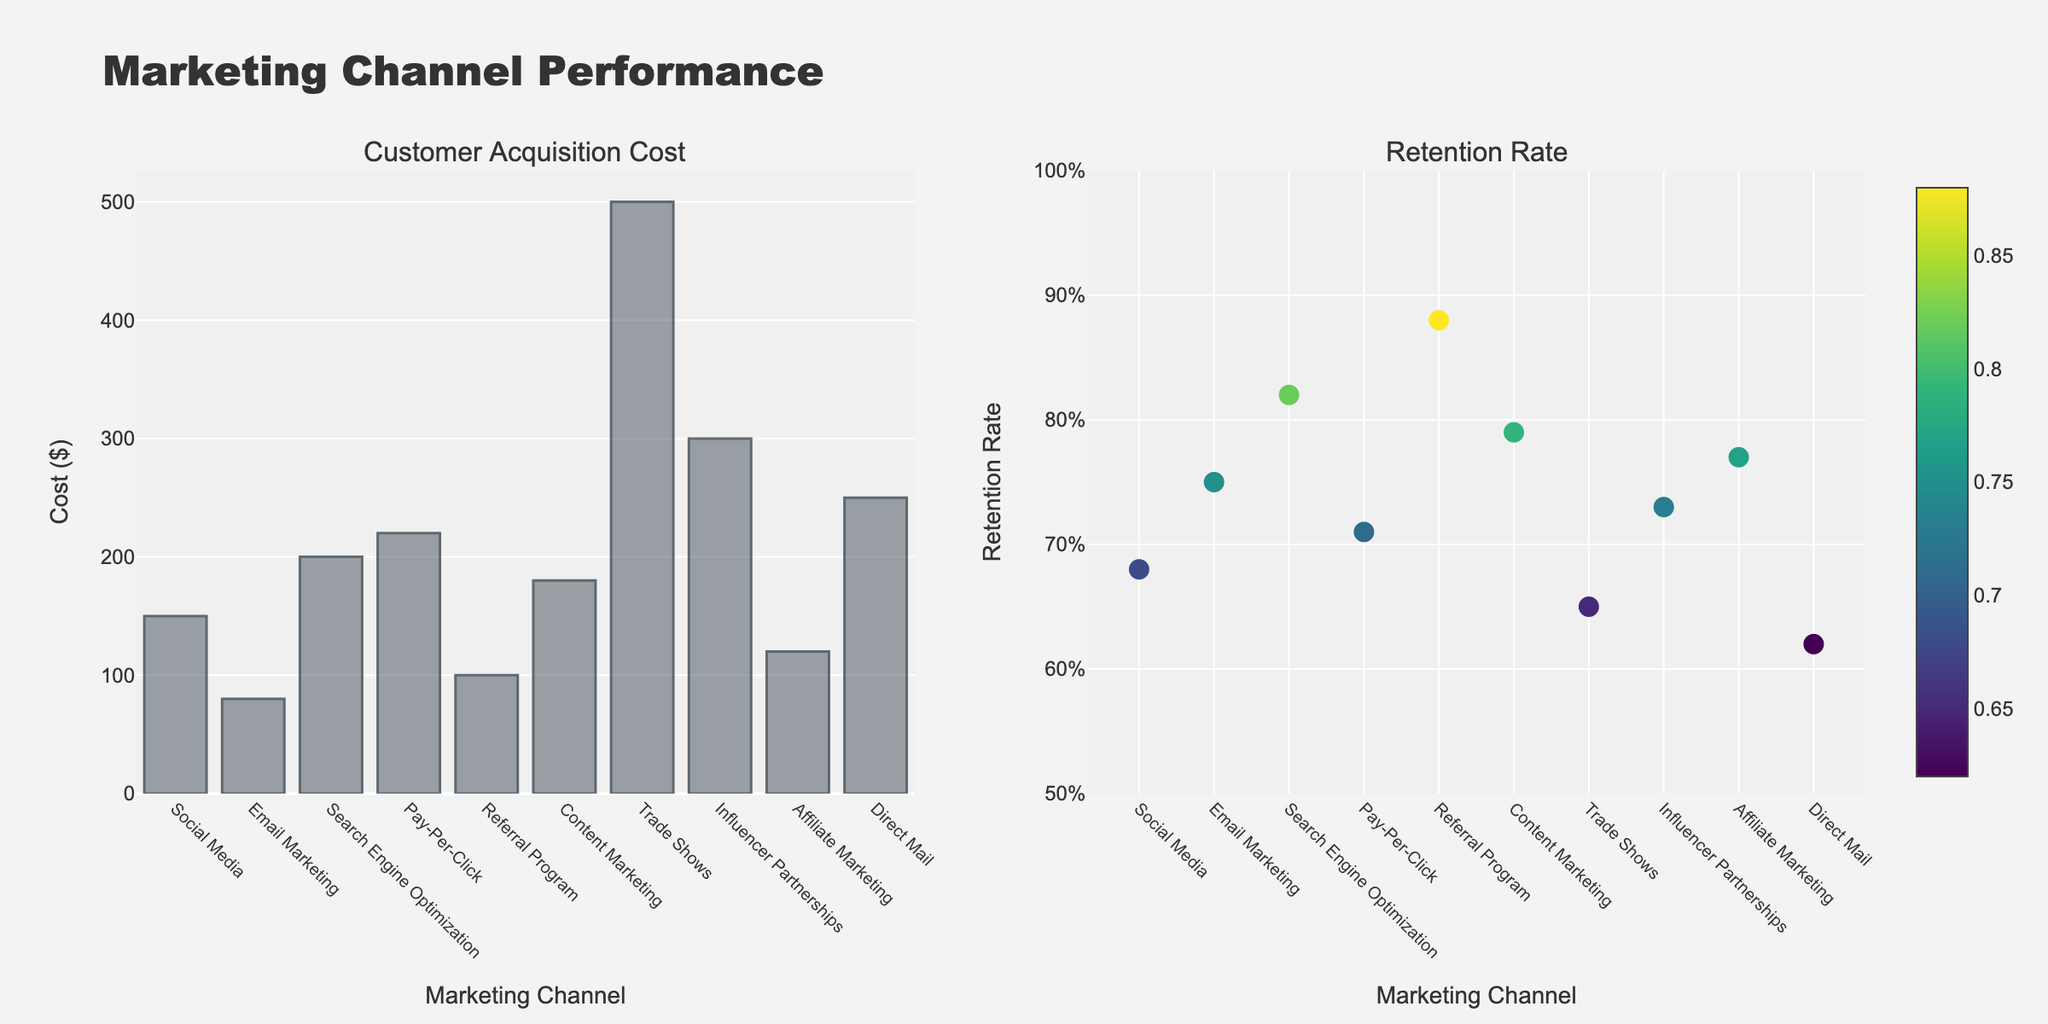What's the Marketing Channel with the highest Customer Acquisition Cost? Observe the left plot (bar chart) and identify the bar with the highest value. The 'Trade Shows' bar is the tallest.
Answer: Trade Shows Which Marketing Channel has the highest Retention Rate? Look at the right plot (scatter chart) and identify the marker that is positioned the highest on the y-axis. The marker for 'Referral Program' is the highest.
Answer: Referral Program Among Social Media and Email Marketing, which has a lower Customer Acquisition Cost? Compare the heights of the bars for 'Social Media' and 'Email Marketing' in the bar chart. The 'Email Marketing' bar is shorter.
Answer: Email Marketing What is the approximate difference in Retention Rate between Pay-Per-Click and Direct Mail? In the scatter plot, find the y-values for 'Pay-Per-Click' (~0.71) and 'Direct Mail' (~0.62). Calculate the difference (0.71 - 0.62).
Answer: 0.09 Which Marketing Channels have a Customer Acquisition Cost greater than $200? Identify the bars in the bar chart that extend above the $200 mark. These are 'Search Engine Optimization', 'Pay-Per-Click', 'Influencer Partnerships', 'Direct Mail', and 'Trade Shows'.
Answer: 5 Is the Retention Rate of Social Media higher than that of Content Marketing? Compare the positions of the 'Social Media' and 'Content Marketing' markers on the scatter plot. The 'Social Media' marker is lower.
Answer: No What is the average Customer Acquisition Cost across all Marketing Channels? Sum the y-values of all bars in the bar chart and divide by the number of bars (150+80+200+220+100+180+500+300+120+250)/10.
Answer: 210 Among the Marketing Channels listed, which one has both the lowest Customer Acquisition Cost and a high Retention Rate? Identify the bar with the shortest height and then check the corresponding marker's position on the scatter plot. 'Email Marketing' has the lowest Customer Acquisition Cost and a high Retention Rate of 0.75.
Answer: Email Marketing How does the Retention Rate of Trade Shows compare to that of Affiliate Marketing? Observe the positions of the 'Trade Shows' and 'Affiliate Marketing' markers on the scatter plot. The 'Trade Shows' marker is lower.
Answer: Lower 